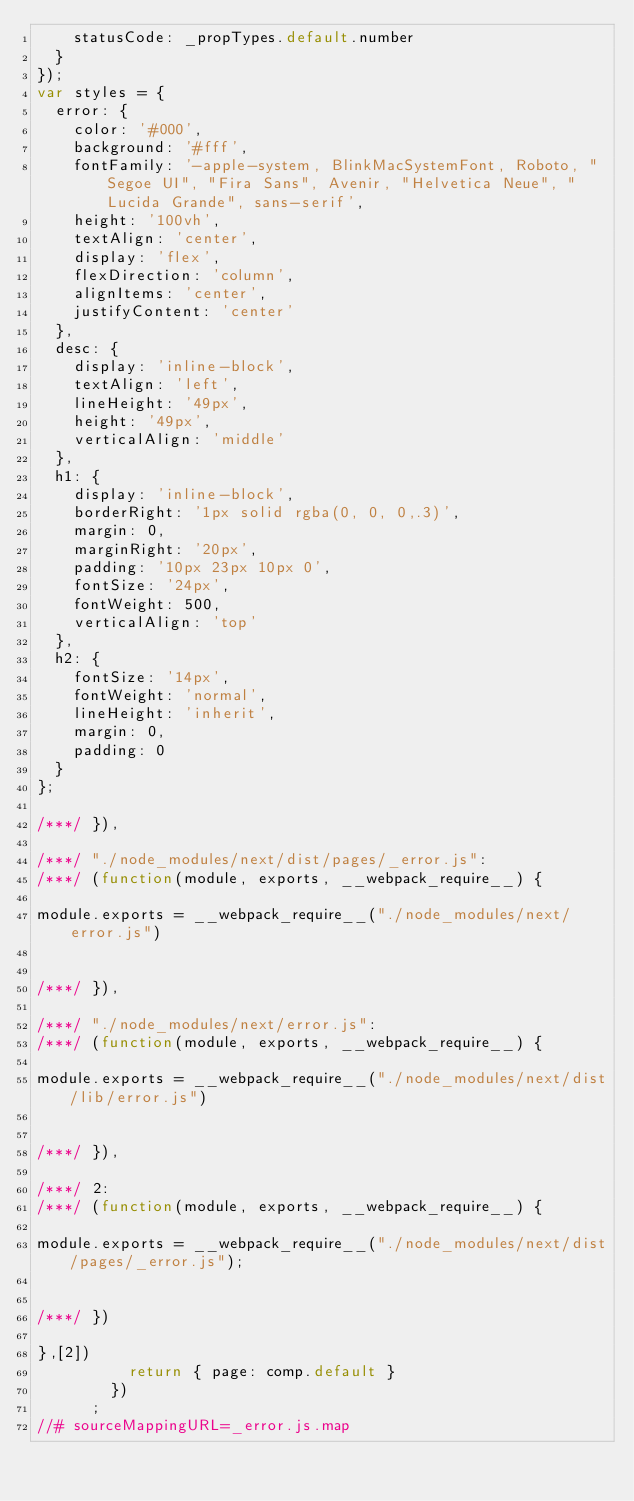<code> <loc_0><loc_0><loc_500><loc_500><_JavaScript_>    statusCode: _propTypes.default.number
  }
});
var styles = {
  error: {
    color: '#000',
    background: '#fff',
    fontFamily: '-apple-system, BlinkMacSystemFont, Roboto, "Segoe UI", "Fira Sans", Avenir, "Helvetica Neue", "Lucida Grande", sans-serif',
    height: '100vh',
    textAlign: 'center',
    display: 'flex',
    flexDirection: 'column',
    alignItems: 'center',
    justifyContent: 'center'
  },
  desc: {
    display: 'inline-block',
    textAlign: 'left',
    lineHeight: '49px',
    height: '49px',
    verticalAlign: 'middle'
  },
  h1: {
    display: 'inline-block',
    borderRight: '1px solid rgba(0, 0, 0,.3)',
    margin: 0,
    marginRight: '20px',
    padding: '10px 23px 10px 0',
    fontSize: '24px',
    fontWeight: 500,
    verticalAlign: 'top'
  },
  h2: {
    fontSize: '14px',
    fontWeight: 'normal',
    lineHeight: 'inherit',
    margin: 0,
    padding: 0
  }
};

/***/ }),

/***/ "./node_modules/next/dist/pages/_error.js":
/***/ (function(module, exports, __webpack_require__) {

module.exports = __webpack_require__("./node_modules/next/error.js")


/***/ }),

/***/ "./node_modules/next/error.js":
/***/ (function(module, exports, __webpack_require__) {

module.exports = __webpack_require__("./node_modules/next/dist/lib/error.js")


/***/ }),

/***/ 2:
/***/ (function(module, exports, __webpack_require__) {

module.exports = __webpack_require__("./node_modules/next/dist/pages/_error.js");


/***/ })

},[2])
          return { page: comp.default }
        })
      ;
//# sourceMappingURL=_error.js.map</code> 